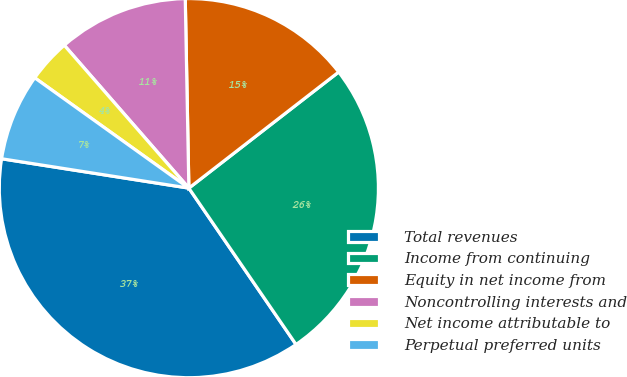Convert chart to OTSL. <chart><loc_0><loc_0><loc_500><loc_500><pie_chart><fcel>Total revenues<fcel>Income from continuing<fcel>Equity in net income from<fcel>Noncontrolling interests and<fcel>Net income attributable to<fcel>Perpetual preferred units<nl><fcel>37.04%<fcel>25.93%<fcel>14.81%<fcel>11.11%<fcel>3.7%<fcel>7.41%<nl></chart> 